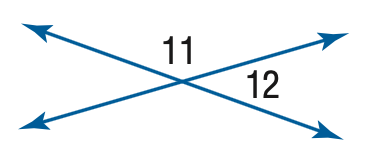Answer the mathemtical geometry problem and directly provide the correct option letter.
Question: m \angle 11 = 4 x, m \angle 12 = 2 x - 6. Find the measure of \angle 12.
Choices: A: 50 B: 52 C: 56 D: 62 C 